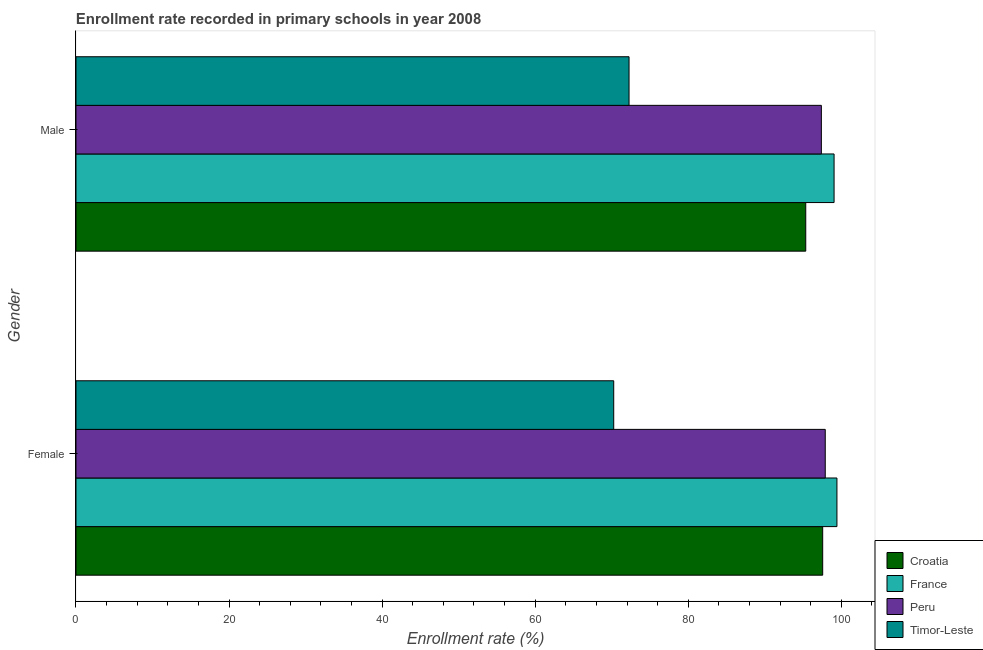How many groups of bars are there?
Your answer should be very brief. 2. Are the number of bars per tick equal to the number of legend labels?
Your answer should be compact. Yes. Are the number of bars on each tick of the Y-axis equal?
Provide a short and direct response. Yes. How many bars are there on the 1st tick from the top?
Your answer should be compact. 4. What is the enrollment rate of male students in France?
Provide a short and direct response. 99.05. Across all countries, what is the maximum enrollment rate of female students?
Provide a short and direct response. 99.43. Across all countries, what is the minimum enrollment rate of female students?
Your answer should be compact. 70.26. In which country was the enrollment rate of male students maximum?
Ensure brevity in your answer.  France. In which country was the enrollment rate of female students minimum?
Provide a short and direct response. Timor-Leste. What is the total enrollment rate of female students in the graph?
Your answer should be very brief. 365.14. What is the difference between the enrollment rate of female students in Peru and that in Timor-Leste?
Ensure brevity in your answer.  27.64. What is the difference between the enrollment rate of female students in France and the enrollment rate of male students in Timor-Leste?
Make the answer very short. 27.16. What is the average enrollment rate of female students per country?
Make the answer very short. 91.29. What is the difference between the enrollment rate of female students and enrollment rate of male students in France?
Offer a very short reply. 0.37. In how many countries, is the enrollment rate of male students greater than 44 %?
Your response must be concise. 4. What is the ratio of the enrollment rate of female students in France to that in Croatia?
Ensure brevity in your answer.  1.02. Is the enrollment rate of male students in France less than that in Croatia?
Your answer should be compact. No. What does the 3rd bar from the top in Female represents?
Offer a terse response. France. What does the 4th bar from the bottom in Male represents?
Your answer should be very brief. Timor-Leste. How many bars are there?
Your answer should be very brief. 8. What is the difference between two consecutive major ticks on the X-axis?
Your response must be concise. 20. Does the graph contain any zero values?
Your answer should be very brief. No. Does the graph contain grids?
Give a very brief answer. No. How many legend labels are there?
Give a very brief answer. 4. How are the legend labels stacked?
Offer a terse response. Vertical. What is the title of the graph?
Provide a succinct answer. Enrollment rate recorded in primary schools in year 2008. Does "Malawi" appear as one of the legend labels in the graph?
Your answer should be compact. No. What is the label or title of the X-axis?
Give a very brief answer. Enrollment rate (%). What is the label or title of the Y-axis?
Provide a succinct answer. Gender. What is the Enrollment rate (%) in Croatia in Female?
Give a very brief answer. 97.56. What is the Enrollment rate (%) of France in Female?
Your answer should be very brief. 99.43. What is the Enrollment rate (%) in Peru in Female?
Provide a succinct answer. 97.9. What is the Enrollment rate (%) of Timor-Leste in Female?
Your answer should be compact. 70.26. What is the Enrollment rate (%) of Croatia in Male?
Offer a terse response. 95.35. What is the Enrollment rate (%) of France in Male?
Ensure brevity in your answer.  99.05. What is the Enrollment rate (%) of Peru in Male?
Your answer should be very brief. 97.39. What is the Enrollment rate (%) of Timor-Leste in Male?
Give a very brief answer. 72.26. Across all Gender, what is the maximum Enrollment rate (%) of Croatia?
Keep it short and to the point. 97.56. Across all Gender, what is the maximum Enrollment rate (%) of France?
Offer a very short reply. 99.43. Across all Gender, what is the maximum Enrollment rate (%) of Peru?
Your answer should be very brief. 97.9. Across all Gender, what is the maximum Enrollment rate (%) in Timor-Leste?
Offer a very short reply. 72.26. Across all Gender, what is the minimum Enrollment rate (%) of Croatia?
Make the answer very short. 95.35. Across all Gender, what is the minimum Enrollment rate (%) in France?
Provide a short and direct response. 99.05. Across all Gender, what is the minimum Enrollment rate (%) of Peru?
Make the answer very short. 97.39. Across all Gender, what is the minimum Enrollment rate (%) in Timor-Leste?
Make the answer very short. 70.26. What is the total Enrollment rate (%) in Croatia in the graph?
Your answer should be compact. 192.91. What is the total Enrollment rate (%) in France in the graph?
Make the answer very short. 198.48. What is the total Enrollment rate (%) in Peru in the graph?
Offer a very short reply. 195.29. What is the total Enrollment rate (%) in Timor-Leste in the graph?
Offer a very short reply. 142.52. What is the difference between the Enrollment rate (%) in Croatia in Female and that in Male?
Offer a terse response. 2.21. What is the difference between the Enrollment rate (%) in France in Female and that in Male?
Your answer should be compact. 0.37. What is the difference between the Enrollment rate (%) in Peru in Female and that in Male?
Keep it short and to the point. 0.51. What is the difference between the Enrollment rate (%) of Timor-Leste in Female and that in Male?
Provide a succinct answer. -2. What is the difference between the Enrollment rate (%) in Croatia in Female and the Enrollment rate (%) in France in Male?
Your response must be concise. -1.49. What is the difference between the Enrollment rate (%) in Croatia in Female and the Enrollment rate (%) in Peru in Male?
Keep it short and to the point. 0.17. What is the difference between the Enrollment rate (%) of Croatia in Female and the Enrollment rate (%) of Timor-Leste in Male?
Offer a very short reply. 25.3. What is the difference between the Enrollment rate (%) of France in Female and the Enrollment rate (%) of Peru in Male?
Ensure brevity in your answer.  2.04. What is the difference between the Enrollment rate (%) of France in Female and the Enrollment rate (%) of Timor-Leste in Male?
Give a very brief answer. 27.16. What is the difference between the Enrollment rate (%) in Peru in Female and the Enrollment rate (%) in Timor-Leste in Male?
Your answer should be compact. 25.64. What is the average Enrollment rate (%) in Croatia per Gender?
Your answer should be compact. 96.46. What is the average Enrollment rate (%) in France per Gender?
Provide a short and direct response. 99.24. What is the average Enrollment rate (%) of Peru per Gender?
Ensure brevity in your answer.  97.64. What is the average Enrollment rate (%) in Timor-Leste per Gender?
Ensure brevity in your answer.  71.26. What is the difference between the Enrollment rate (%) in Croatia and Enrollment rate (%) in France in Female?
Your answer should be very brief. -1.86. What is the difference between the Enrollment rate (%) of Croatia and Enrollment rate (%) of Peru in Female?
Your answer should be very brief. -0.33. What is the difference between the Enrollment rate (%) of Croatia and Enrollment rate (%) of Timor-Leste in Female?
Offer a terse response. 27.3. What is the difference between the Enrollment rate (%) in France and Enrollment rate (%) in Peru in Female?
Make the answer very short. 1.53. What is the difference between the Enrollment rate (%) in France and Enrollment rate (%) in Timor-Leste in Female?
Your answer should be very brief. 29.17. What is the difference between the Enrollment rate (%) in Peru and Enrollment rate (%) in Timor-Leste in Female?
Give a very brief answer. 27.64. What is the difference between the Enrollment rate (%) in Croatia and Enrollment rate (%) in France in Male?
Provide a succinct answer. -3.7. What is the difference between the Enrollment rate (%) in Croatia and Enrollment rate (%) in Peru in Male?
Ensure brevity in your answer.  -2.04. What is the difference between the Enrollment rate (%) of Croatia and Enrollment rate (%) of Timor-Leste in Male?
Offer a very short reply. 23.09. What is the difference between the Enrollment rate (%) in France and Enrollment rate (%) in Peru in Male?
Make the answer very short. 1.66. What is the difference between the Enrollment rate (%) in France and Enrollment rate (%) in Timor-Leste in Male?
Your response must be concise. 26.79. What is the difference between the Enrollment rate (%) of Peru and Enrollment rate (%) of Timor-Leste in Male?
Keep it short and to the point. 25.13. What is the ratio of the Enrollment rate (%) in Croatia in Female to that in Male?
Keep it short and to the point. 1.02. What is the ratio of the Enrollment rate (%) in France in Female to that in Male?
Your response must be concise. 1. What is the ratio of the Enrollment rate (%) in Timor-Leste in Female to that in Male?
Provide a succinct answer. 0.97. What is the difference between the highest and the second highest Enrollment rate (%) in Croatia?
Keep it short and to the point. 2.21. What is the difference between the highest and the second highest Enrollment rate (%) in France?
Provide a succinct answer. 0.37. What is the difference between the highest and the second highest Enrollment rate (%) of Peru?
Make the answer very short. 0.51. What is the difference between the highest and the second highest Enrollment rate (%) of Timor-Leste?
Your answer should be very brief. 2. What is the difference between the highest and the lowest Enrollment rate (%) in Croatia?
Provide a short and direct response. 2.21. What is the difference between the highest and the lowest Enrollment rate (%) of France?
Keep it short and to the point. 0.37. What is the difference between the highest and the lowest Enrollment rate (%) of Peru?
Provide a short and direct response. 0.51. What is the difference between the highest and the lowest Enrollment rate (%) of Timor-Leste?
Provide a short and direct response. 2. 